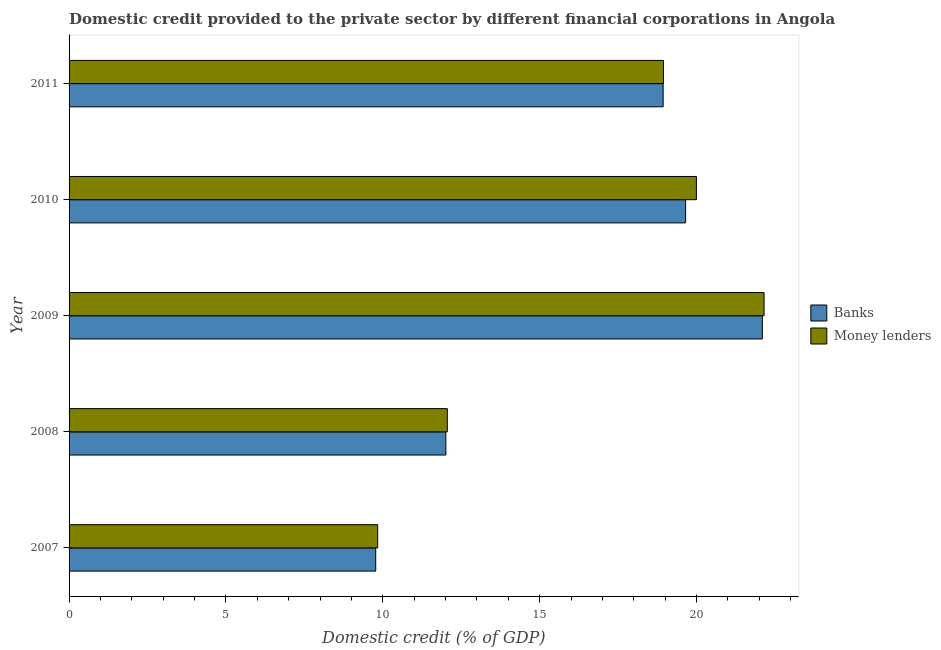How many different coloured bars are there?
Offer a very short reply. 2. How many groups of bars are there?
Offer a terse response. 5. How many bars are there on the 1st tick from the top?
Provide a short and direct response. 2. How many bars are there on the 2nd tick from the bottom?
Your response must be concise. 2. What is the domestic credit provided by banks in 2009?
Make the answer very short. 22.1. Across all years, what is the maximum domestic credit provided by banks?
Provide a succinct answer. 22.1. Across all years, what is the minimum domestic credit provided by money lenders?
Your answer should be compact. 9.84. In which year was the domestic credit provided by banks maximum?
Provide a short and direct response. 2009. In which year was the domestic credit provided by banks minimum?
Give a very brief answer. 2007. What is the total domestic credit provided by money lenders in the graph?
Offer a terse response. 82.99. What is the difference between the domestic credit provided by money lenders in 2010 and that in 2011?
Provide a succinct answer. 1.05. What is the difference between the domestic credit provided by banks in 2008 and the domestic credit provided by money lenders in 2007?
Offer a terse response. 2.17. What is the average domestic credit provided by money lenders per year?
Give a very brief answer. 16.6. In the year 2009, what is the difference between the domestic credit provided by money lenders and domestic credit provided by banks?
Offer a terse response. 0.05. What is the ratio of the domestic credit provided by money lenders in 2008 to that in 2009?
Ensure brevity in your answer.  0.54. Is the domestic credit provided by money lenders in 2008 less than that in 2011?
Provide a succinct answer. Yes. Is the difference between the domestic credit provided by money lenders in 2008 and 2010 greater than the difference between the domestic credit provided by banks in 2008 and 2010?
Offer a very short reply. No. What is the difference between the highest and the second highest domestic credit provided by money lenders?
Give a very brief answer. 2.16. What is the difference between the highest and the lowest domestic credit provided by banks?
Ensure brevity in your answer.  12.32. In how many years, is the domestic credit provided by money lenders greater than the average domestic credit provided by money lenders taken over all years?
Your answer should be compact. 3. What does the 1st bar from the top in 2011 represents?
Offer a very short reply. Money lenders. What does the 1st bar from the bottom in 2007 represents?
Your answer should be compact. Banks. Are all the bars in the graph horizontal?
Your response must be concise. Yes. How many years are there in the graph?
Make the answer very short. 5. Does the graph contain any zero values?
Your response must be concise. No. Does the graph contain grids?
Provide a succinct answer. No. How are the legend labels stacked?
Offer a terse response. Vertical. What is the title of the graph?
Keep it short and to the point. Domestic credit provided to the private sector by different financial corporations in Angola. What is the label or title of the X-axis?
Ensure brevity in your answer.  Domestic credit (% of GDP). What is the Domestic credit (% of GDP) in Banks in 2007?
Give a very brief answer. 9.77. What is the Domestic credit (% of GDP) in Money lenders in 2007?
Provide a succinct answer. 9.84. What is the Domestic credit (% of GDP) of Banks in 2008?
Your answer should be very brief. 12.01. What is the Domestic credit (% of GDP) of Money lenders in 2008?
Your answer should be very brief. 12.06. What is the Domestic credit (% of GDP) of Banks in 2009?
Keep it short and to the point. 22.1. What is the Domestic credit (% of GDP) of Money lenders in 2009?
Offer a very short reply. 22.15. What is the Domestic credit (% of GDP) in Banks in 2010?
Offer a terse response. 19.65. What is the Domestic credit (% of GDP) in Money lenders in 2010?
Offer a terse response. 20. What is the Domestic credit (% of GDP) of Banks in 2011?
Make the answer very short. 18.94. What is the Domestic credit (% of GDP) in Money lenders in 2011?
Offer a very short reply. 18.95. Across all years, what is the maximum Domestic credit (% of GDP) of Banks?
Offer a terse response. 22.1. Across all years, what is the maximum Domestic credit (% of GDP) of Money lenders?
Offer a very short reply. 22.15. Across all years, what is the minimum Domestic credit (% of GDP) in Banks?
Keep it short and to the point. 9.77. Across all years, what is the minimum Domestic credit (% of GDP) of Money lenders?
Your answer should be very brief. 9.84. What is the total Domestic credit (% of GDP) of Banks in the graph?
Provide a succinct answer. 82.48. What is the total Domestic credit (% of GDP) of Money lenders in the graph?
Keep it short and to the point. 82.99. What is the difference between the Domestic credit (% of GDP) in Banks in 2007 and that in 2008?
Offer a very short reply. -2.24. What is the difference between the Domestic credit (% of GDP) of Money lenders in 2007 and that in 2008?
Offer a terse response. -2.22. What is the difference between the Domestic credit (% of GDP) in Banks in 2007 and that in 2009?
Give a very brief answer. -12.32. What is the difference between the Domestic credit (% of GDP) of Money lenders in 2007 and that in 2009?
Your answer should be very brief. -12.32. What is the difference between the Domestic credit (% of GDP) of Banks in 2007 and that in 2010?
Give a very brief answer. -9.88. What is the difference between the Domestic credit (% of GDP) in Money lenders in 2007 and that in 2010?
Make the answer very short. -10.16. What is the difference between the Domestic credit (% of GDP) of Banks in 2007 and that in 2011?
Provide a short and direct response. -9.16. What is the difference between the Domestic credit (% of GDP) in Money lenders in 2007 and that in 2011?
Keep it short and to the point. -9.11. What is the difference between the Domestic credit (% of GDP) of Banks in 2008 and that in 2009?
Your answer should be compact. -10.09. What is the difference between the Domestic credit (% of GDP) in Money lenders in 2008 and that in 2009?
Your answer should be compact. -10.1. What is the difference between the Domestic credit (% of GDP) in Banks in 2008 and that in 2010?
Your answer should be compact. -7.64. What is the difference between the Domestic credit (% of GDP) in Money lenders in 2008 and that in 2010?
Make the answer very short. -7.94. What is the difference between the Domestic credit (% of GDP) of Banks in 2008 and that in 2011?
Provide a succinct answer. -6.93. What is the difference between the Domestic credit (% of GDP) of Money lenders in 2008 and that in 2011?
Provide a short and direct response. -6.89. What is the difference between the Domestic credit (% of GDP) of Banks in 2009 and that in 2010?
Provide a short and direct response. 2.45. What is the difference between the Domestic credit (% of GDP) in Money lenders in 2009 and that in 2010?
Provide a short and direct response. 2.16. What is the difference between the Domestic credit (% of GDP) in Banks in 2009 and that in 2011?
Make the answer very short. 3.16. What is the difference between the Domestic credit (% of GDP) in Money lenders in 2009 and that in 2011?
Your response must be concise. 3.21. What is the difference between the Domestic credit (% of GDP) in Banks in 2010 and that in 2011?
Provide a succinct answer. 0.72. What is the difference between the Domestic credit (% of GDP) in Money lenders in 2010 and that in 2011?
Keep it short and to the point. 1.05. What is the difference between the Domestic credit (% of GDP) in Banks in 2007 and the Domestic credit (% of GDP) in Money lenders in 2008?
Your answer should be compact. -2.28. What is the difference between the Domestic credit (% of GDP) in Banks in 2007 and the Domestic credit (% of GDP) in Money lenders in 2009?
Keep it short and to the point. -12.38. What is the difference between the Domestic credit (% of GDP) of Banks in 2007 and the Domestic credit (% of GDP) of Money lenders in 2010?
Your answer should be compact. -10.22. What is the difference between the Domestic credit (% of GDP) of Banks in 2007 and the Domestic credit (% of GDP) of Money lenders in 2011?
Keep it short and to the point. -9.17. What is the difference between the Domestic credit (% of GDP) of Banks in 2008 and the Domestic credit (% of GDP) of Money lenders in 2009?
Ensure brevity in your answer.  -10.14. What is the difference between the Domestic credit (% of GDP) in Banks in 2008 and the Domestic credit (% of GDP) in Money lenders in 2010?
Provide a short and direct response. -7.99. What is the difference between the Domestic credit (% of GDP) of Banks in 2008 and the Domestic credit (% of GDP) of Money lenders in 2011?
Your response must be concise. -6.94. What is the difference between the Domestic credit (% of GDP) in Banks in 2009 and the Domestic credit (% of GDP) in Money lenders in 2010?
Make the answer very short. 2.1. What is the difference between the Domestic credit (% of GDP) in Banks in 2009 and the Domestic credit (% of GDP) in Money lenders in 2011?
Your response must be concise. 3.15. What is the difference between the Domestic credit (% of GDP) of Banks in 2010 and the Domestic credit (% of GDP) of Money lenders in 2011?
Your answer should be compact. 0.71. What is the average Domestic credit (% of GDP) of Banks per year?
Make the answer very short. 16.5. What is the average Domestic credit (% of GDP) in Money lenders per year?
Your answer should be compact. 16.6. In the year 2007, what is the difference between the Domestic credit (% of GDP) in Banks and Domestic credit (% of GDP) in Money lenders?
Provide a short and direct response. -0.06. In the year 2008, what is the difference between the Domestic credit (% of GDP) of Banks and Domestic credit (% of GDP) of Money lenders?
Provide a short and direct response. -0.05. In the year 2009, what is the difference between the Domestic credit (% of GDP) in Banks and Domestic credit (% of GDP) in Money lenders?
Make the answer very short. -0.05. In the year 2010, what is the difference between the Domestic credit (% of GDP) in Banks and Domestic credit (% of GDP) in Money lenders?
Offer a very short reply. -0.34. In the year 2011, what is the difference between the Domestic credit (% of GDP) in Banks and Domestic credit (% of GDP) in Money lenders?
Give a very brief answer. -0.01. What is the ratio of the Domestic credit (% of GDP) of Banks in 2007 to that in 2008?
Ensure brevity in your answer.  0.81. What is the ratio of the Domestic credit (% of GDP) of Money lenders in 2007 to that in 2008?
Keep it short and to the point. 0.82. What is the ratio of the Domestic credit (% of GDP) in Banks in 2007 to that in 2009?
Make the answer very short. 0.44. What is the ratio of the Domestic credit (% of GDP) in Money lenders in 2007 to that in 2009?
Provide a short and direct response. 0.44. What is the ratio of the Domestic credit (% of GDP) in Banks in 2007 to that in 2010?
Your answer should be compact. 0.5. What is the ratio of the Domestic credit (% of GDP) in Money lenders in 2007 to that in 2010?
Keep it short and to the point. 0.49. What is the ratio of the Domestic credit (% of GDP) of Banks in 2007 to that in 2011?
Your response must be concise. 0.52. What is the ratio of the Domestic credit (% of GDP) of Money lenders in 2007 to that in 2011?
Provide a short and direct response. 0.52. What is the ratio of the Domestic credit (% of GDP) of Banks in 2008 to that in 2009?
Your response must be concise. 0.54. What is the ratio of the Domestic credit (% of GDP) of Money lenders in 2008 to that in 2009?
Offer a very short reply. 0.54. What is the ratio of the Domestic credit (% of GDP) in Banks in 2008 to that in 2010?
Make the answer very short. 0.61. What is the ratio of the Domestic credit (% of GDP) in Money lenders in 2008 to that in 2010?
Provide a short and direct response. 0.6. What is the ratio of the Domestic credit (% of GDP) in Banks in 2008 to that in 2011?
Ensure brevity in your answer.  0.63. What is the ratio of the Domestic credit (% of GDP) in Money lenders in 2008 to that in 2011?
Keep it short and to the point. 0.64. What is the ratio of the Domestic credit (% of GDP) in Banks in 2009 to that in 2010?
Your answer should be very brief. 1.12. What is the ratio of the Domestic credit (% of GDP) in Money lenders in 2009 to that in 2010?
Your answer should be compact. 1.11. What is the ratio of the Domestic credit (% of GDP) in Banks in 2009 to that in 2011?
Offer a terse response. 1.17. What is the ratio of the Domestic credit (% of GDP) of Money lenders in 2009 to that in 2011?
Offer a terse response. 1.17. What is the ratio of the Domestic credit (% of GDP) in Banks in 2010 to that in 2011?
Provide a succinct answer. 1.04. What is the ratio of the Domestic credit (% of GDP) of Money lenders in 2010 to that in 2011?
Provide a succinct answer. 1.06. What is the difference between the highest and the second highest Domestic credit (% of GDP) of Banks?
Your answer should be compact. 2.45. What is the difference between the highest and the second highest Domestic credit (% of GDP) in Money lenders?
Ensure brevity in your answer.  2.16. What is the difference between the highest and the lowest Domestic credit (% of GDP) in Banks?
Your response must be concise. 12.32. What is the difference between the highest and the lowest Domestic credit (% of GDP) of Money lenders?
Offer a very short reply. 12.32. 